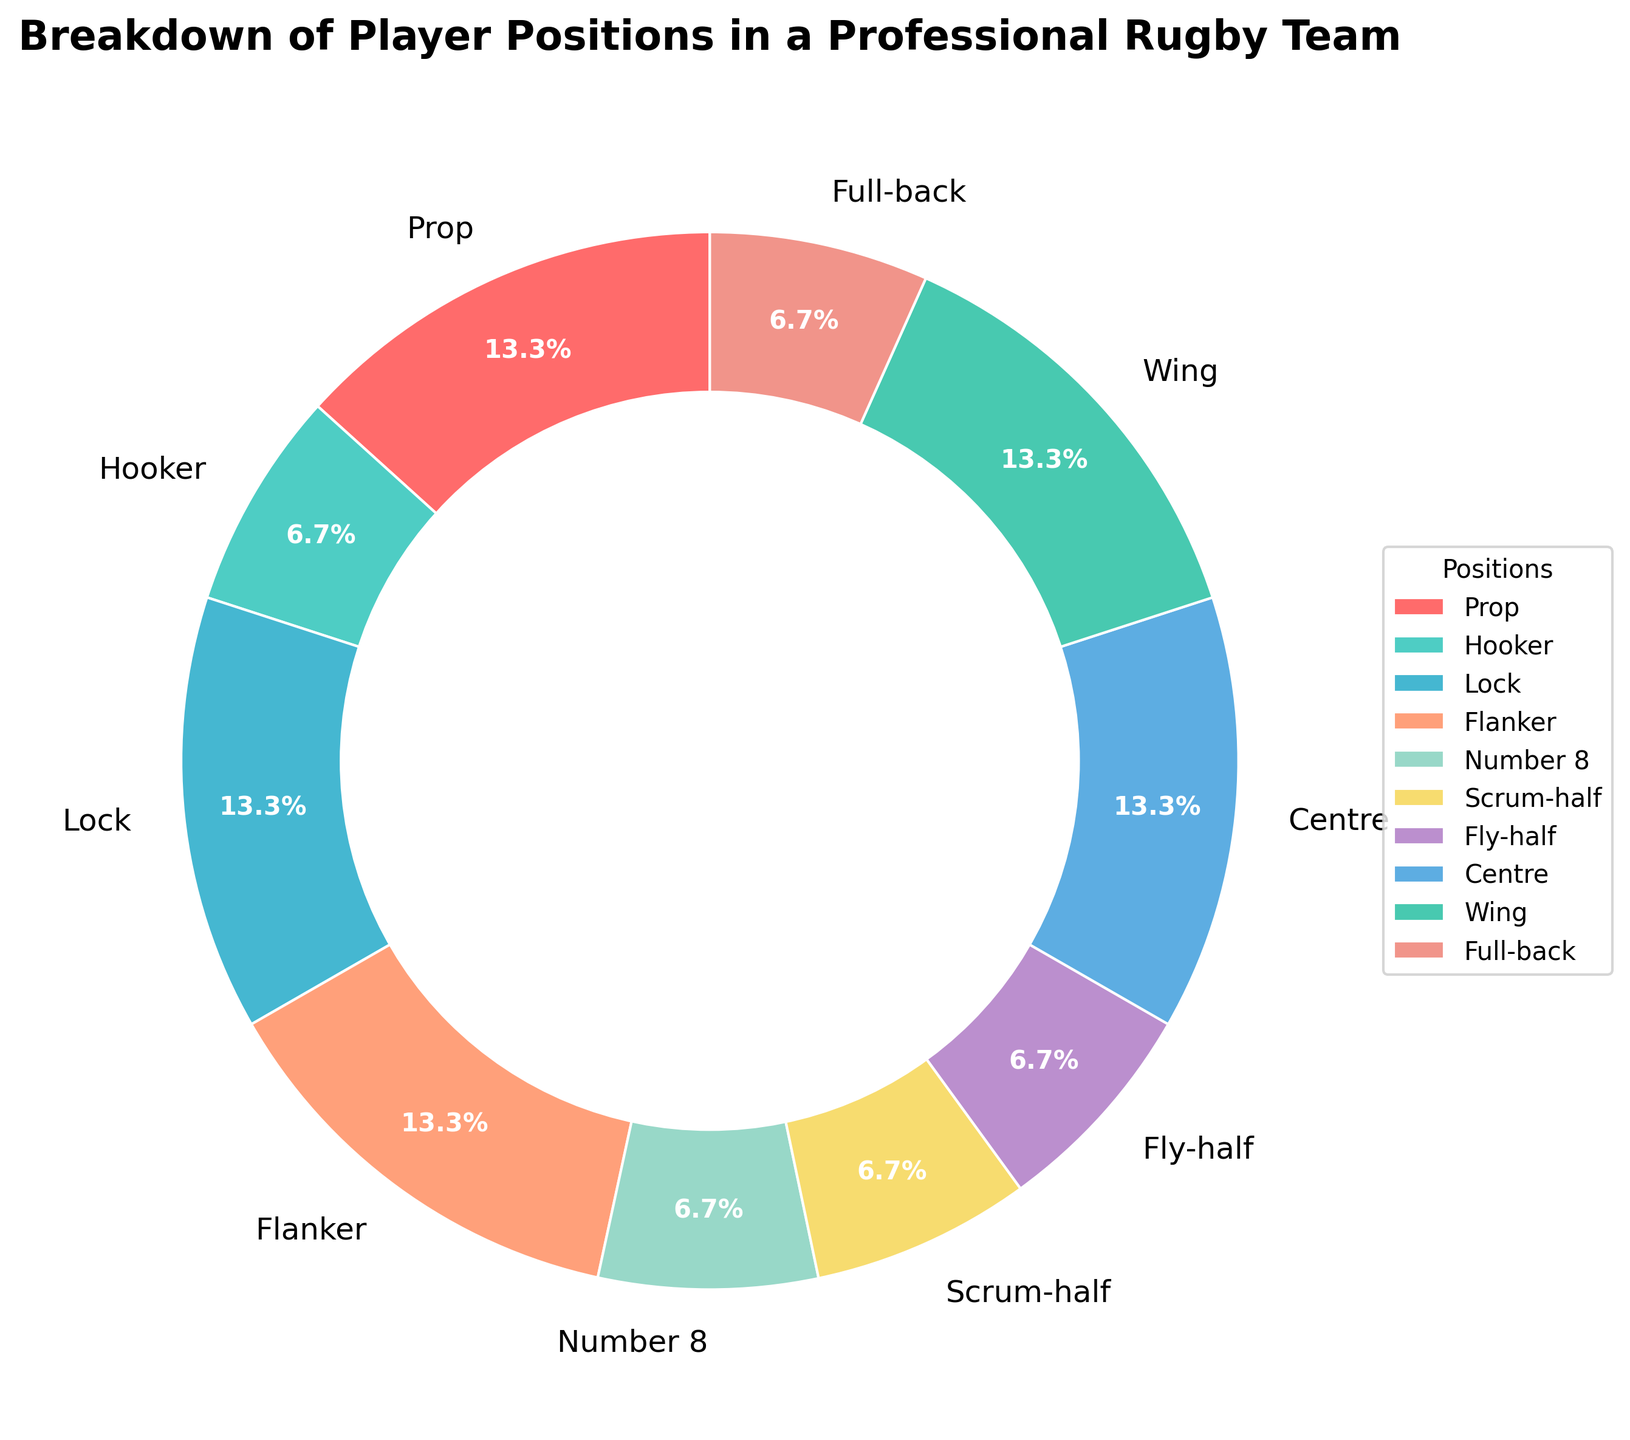What's the most common player position on the team based on the chart? The chart shows that Prop, Lock, Flanker, Centre, and Wing each occupy 13.3% of the team. Since this is the highest percentage among all player positions, these five positions are the most common.
Answer: Prop, Lock, Flanker, Centre, Wing Which positional group has the smallest representation in the team according to the pie chart? The chart indicates that Hooker, Number 8, Scrum-half, Fly-half, and Full-back each make up 6.7% of the team. Multiple positions share this smallest percentage.
Answer: Hooker, Number 8, Scrum-half, Fly-half, Full-back Compare the total percentage of forwards (Prop, Hooker, Lock, Flanker, Number 8) versus backs (Scrum-half, Fly-half, Centre, Wing, Full-back). Which group has a higher percentage? First, sum the percentages for the forward positions: 13.3 + 6.7 + 13.3 + 13.3 + 6.7 = 53.3%. Then, sum the percentages for the backs: 6.7 + 6.7 + 13.3 + 13.3 + 6.7 = 46.7%. Forwards have a higher percentage.
Answer: Forwards What is the combined percentage of positions typically part of the scrum (Prop, Hooker, Lock)? To find the combined percentage of Prop, Hooker, and Lock, sum up their individual percentages: 13.3 + 6.7 + 13.3 = 33.3%.
Answer: 33.3% How much larger is the total percentage for Centres and Wingers compared to Fly-halves and Full-backs? First, sum the percentages for Centres and Wingers: 13.3 + 13.3 = 26.6%. Then, sum the percentages for Fly-halves and Full-backs: 6.7 + 6.7 = 13.4%. Subtract to find the difference: 26.6 - 13.4 = 13.2%.
Answer: 13.2% What color represents the position of 'Flanker' in the chart? The chart uses specific colors for each position, and Flanker's color is identifiable in the wedge labeled as Flanker in the pie chart. The color used for Flanker is a light greenish-blue (#45B7D1).
Answer: Light greenish-blue If you added up the percentages of Prop, Flanker, and Centre, would they account for more than half of the team's positions? To find the total percentage for Prop, Flanker, and Centre, calculate: 13.3 + 13.3 + 13.3 = 39.9%. This is less than half (50%) of the team’s positions.
Answer: No Determine the average percentage representation of Wing, Full-back, Fly-half, and Scrum-half. Sum their percentages and divide by the number of positions: (13.3 + 6.7 + 6.7 + 6.7) / 4 = 33.4 / 4 = 8.35%.
Answer: 8.35% 